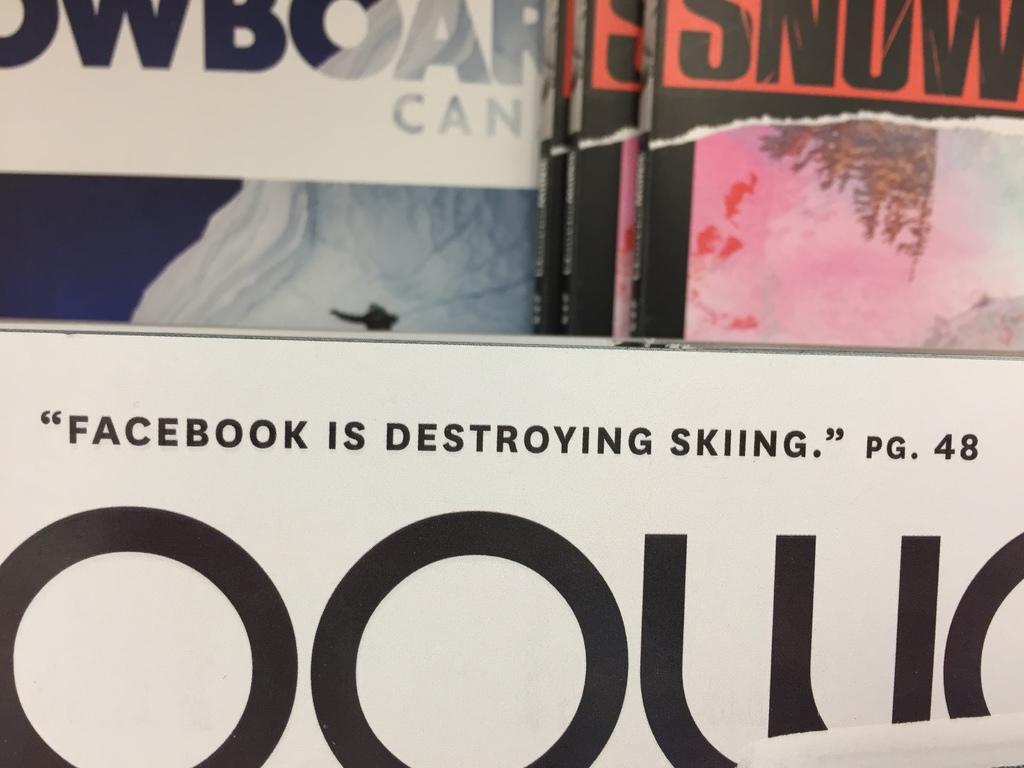<image>
Describe the image concisely. An issue of Snow magazine has an articled entitled Facebook is Destroying Skiing. 